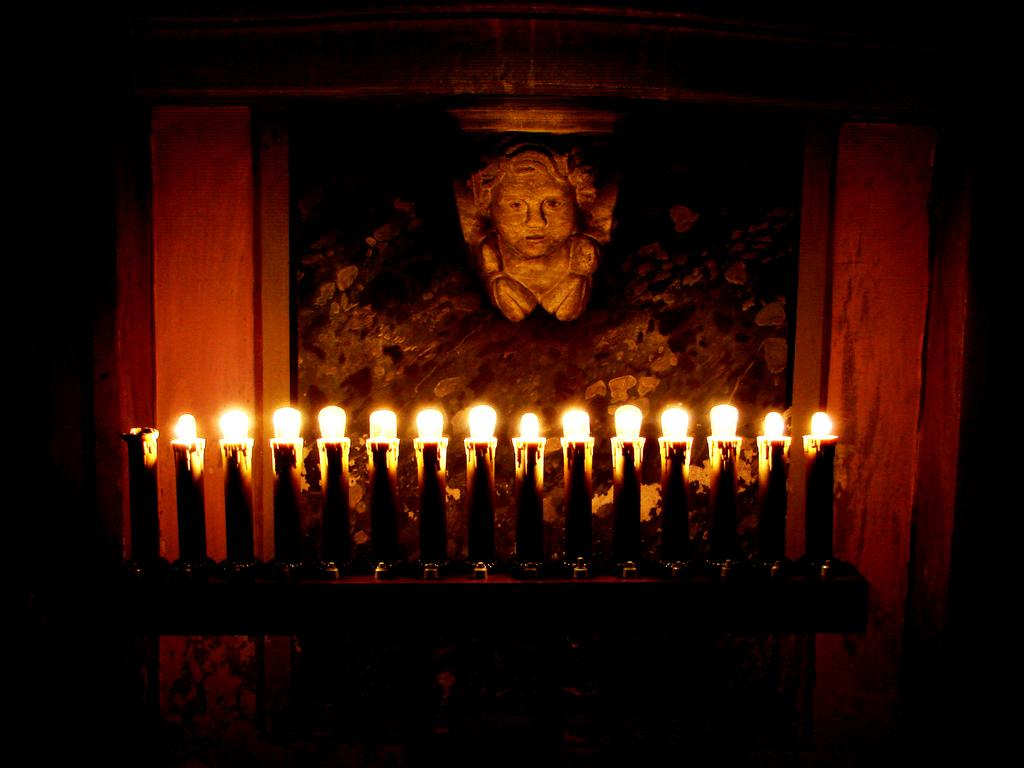What objects are on a platform in the image? There are candles on a platform in the image. What can be seen on the wall in the image? There is a photo frame on the wall in the image. What type of kettle is used for pleasure in the image? There is no kettle present in the image, and the concept of pleasure is not relevant to the objects depicted. 